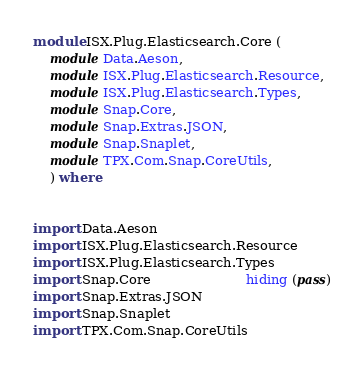Convert code to text. <code><loc_0><loc_0><loc_500><loc_500><_Haskell_>module ISX.Plug.Elasticsearch.Core (
    module Data.Aeson,
    module ISX.Plug.Elasticsearch.Resource,
    module ISX.Plug.Elasticsearch.Types,
    module Snap.Core,
    module Snap.Extras.JSON,
    module Snap.Snaplet,
    module TPX.Com.Snap.CoreUtils,
    ) where


import Data.Aeson
import ISX.Plug.Elasticsearch.Resource
import ISX.Plug.Elasticsearch.Types
import Snap.Core                       hiding (pass)
import Snap.Extras.JSON
import Snap.Snaplet
import TPX.Com.Snap.CoreUtils
</code> 